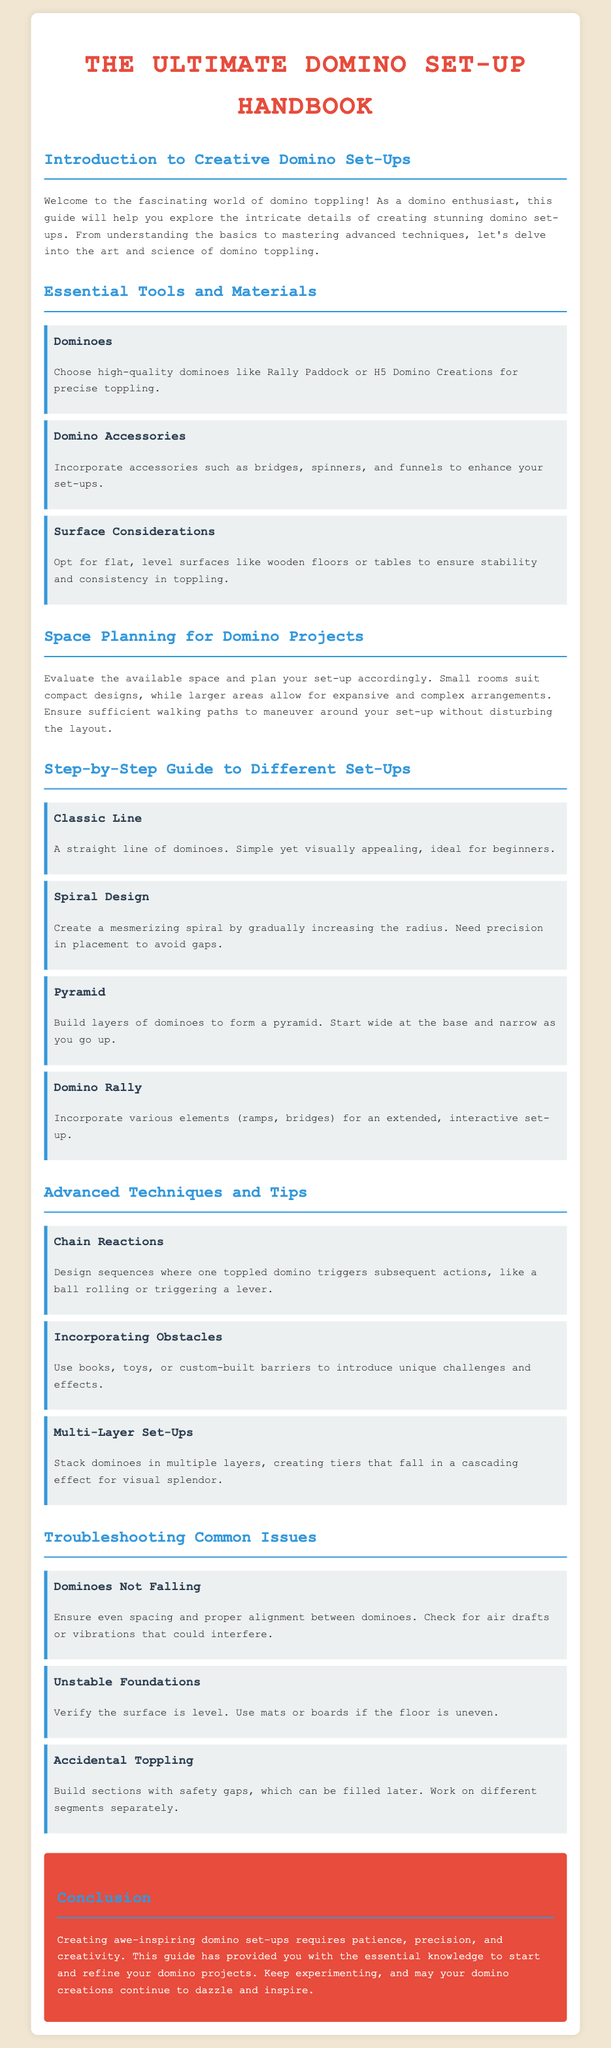What is the title of the handbook? The title is prominently displayed at the top of the document and is central to its purpose.
Answer: The Ultimate Domino Set-Up Handbook Which type of domino is suggested for precise toppling? The handbook lists specific domino types under the essential tools and materials section.
Answer: Rally Paddock What design is ideal for beginners? The document mentions a specific setup style in the step-by-step guide section that is simple yet visually appealing.
Answer: Classic Line What surface is recommended for domino setups? The handbook advises on surface considerations to ensure stability in toppling, listing specific types.
Answer: Flat, level surfaces What technique involves using multiple layers? The advanced techniques section discusses a specific method known for its visual effects and complexity.
Answer: Multi-Layer Set-Ups What is a common issue related to dominoes not falling? The troubleshooting section outlines a specific factor that might cause this problem, which is listed as a solution.
Answer: Spacing and alignment How should you plan space for a domino project? The document suggests a consideration that helps to evaluate available space relevant to setups.
Answer: Evaluate space availability What is one obstacle suggestion mentioned? The advanced techniques section provides examples of objects that can introduce challenges to domino setups.
Answer: Books, toys, barriers 